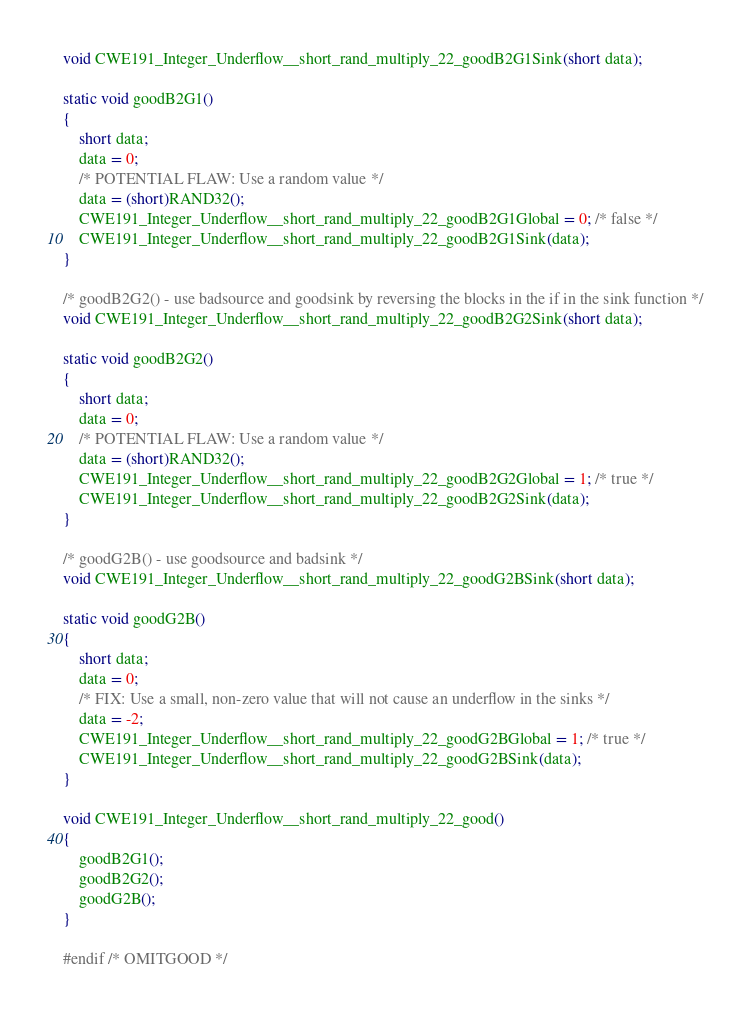Convert code to text. <code><loc_0><loc_0><loc_500><loc_500><_C_>void CWE191_Integer_Underflow__short_rand_multiply_22_goodB2G1Sink(short data);

static void goodB2G1()
{
    short data;
    data = 0;
    /* POTENTIAL FLAW: Use a random value */
    data = (short)RAND32();
    CWE191_Integer_Underflow__short_rand_multiply_22_goodB2G1Global = 0; /* false */
    CWE191_Integer_Underflow__short_rand_multiply_22_goodB2G1Sink(data);
}

/* goodB2G2() - use badsource and goodsink by reversing the blocks in the if in the sink function */
void CWE191_Integer_Underflow__short_rand_multiply_22_goodB2G2Sink(short data);

static void goodB2G2()
{
    short data;
    data = 0;
    /* POTENTIAL FLAW: Use a random value */
    data = (short)RAND32();
    CWE191_Integer_Underflow__short_rand_multiply_22_goodB2G2Global = 1; /* true */
    CWE191_Integer_Underflow__short_rand_multiply_22_goodB2G2Sink(data);
}

/* goodG2B() - use goodsource and badsink */
void CWE191_Integer_Underflow__short_rand_multiply_22_goodG2BSink(short data);

static void goodG2B()
{
    short data;
    data = 0;
    /* FIX: Use a small, non-zero value that will not cause an underflow in the sinks */
    data = -2;
    CWE191_Integer_Underflow__short_rand_multiply_22_goodG2BGlobal = 1; /* true */
    CWE191_Integer_Underflow__short_rand_multiply_22_goodG2BSink(data);
}

void CWE191_Integer_Underflow__short_rand_multiply_22_good()
{
    goodB2G1();
    goodB2G2();
    goodG2B();
}

#endif /* OMITGOOD */
</code> 